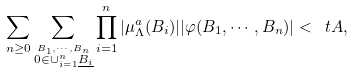<formula> <loc_0><loc_0><loc_500><loc_500>\sum _ { n \geq 0 } \sum _ { \stackrel { B _ { 1 } , \cdots , B _ { n } } { 0 \in \cup _ { i = 1 } ^ { n } \underline { B _ { i } } } } \prod _ { i = 1 } ^ { n } | \mu _ { \Lambda } ^ { a } ( B _ { i } ) | | \varphi ( B _ { 1 } , \cdots , B _ { n } ) | < \ t A ,</formula> 